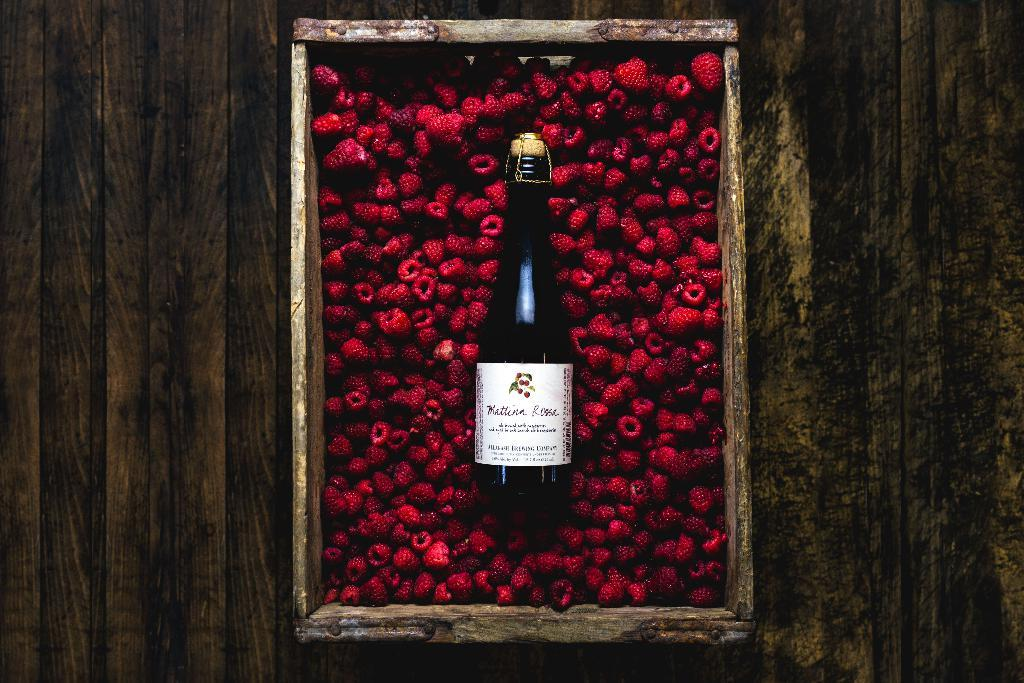<image>
Summarize the visual content of the image. Bottle inside a pile of red fruits and says "Mattina" on the label. 